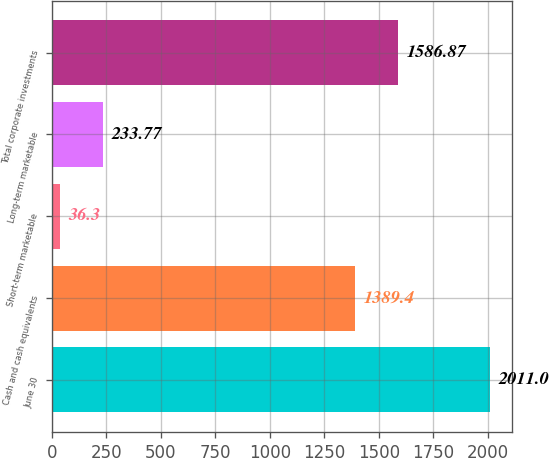<chart> <loc_0><loc_0><loc_500><loc_500><bar_chart><fcel>June 30<fcel>Cash and cash equivalents<fcel>Short-term marketable<fcel>Long-term marketable<fcel>Total corporate investments<nl><fcel>2011<fcel>1389.4<fcel>36.3<fcel>233.77<fcel>1586.87<nl></chart> 